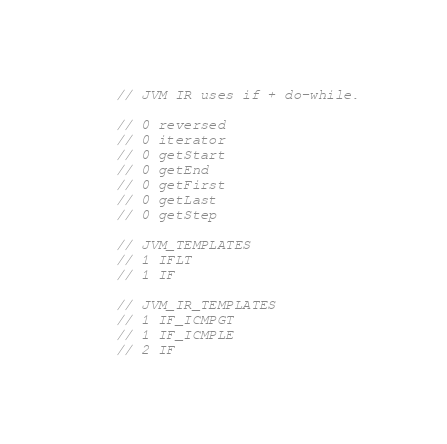<code> <loc_0><loc_0><loc_500><loc_500><_Kotlin_>// JVM IR uses if + do-while.

// 0 reversed
// 0 iterator
// 0 getStart
// 0 getEnd
// 0 getFirst
// 0 getLast
// 0 getStep

// JVM_TEMPLATES
// 1 IFLT
// 1 IF

// JVM_IR_TEMPLATES
// 1 IF_ICMPGT
// 1 IF_ICMPLE
// 2 IF</code> 